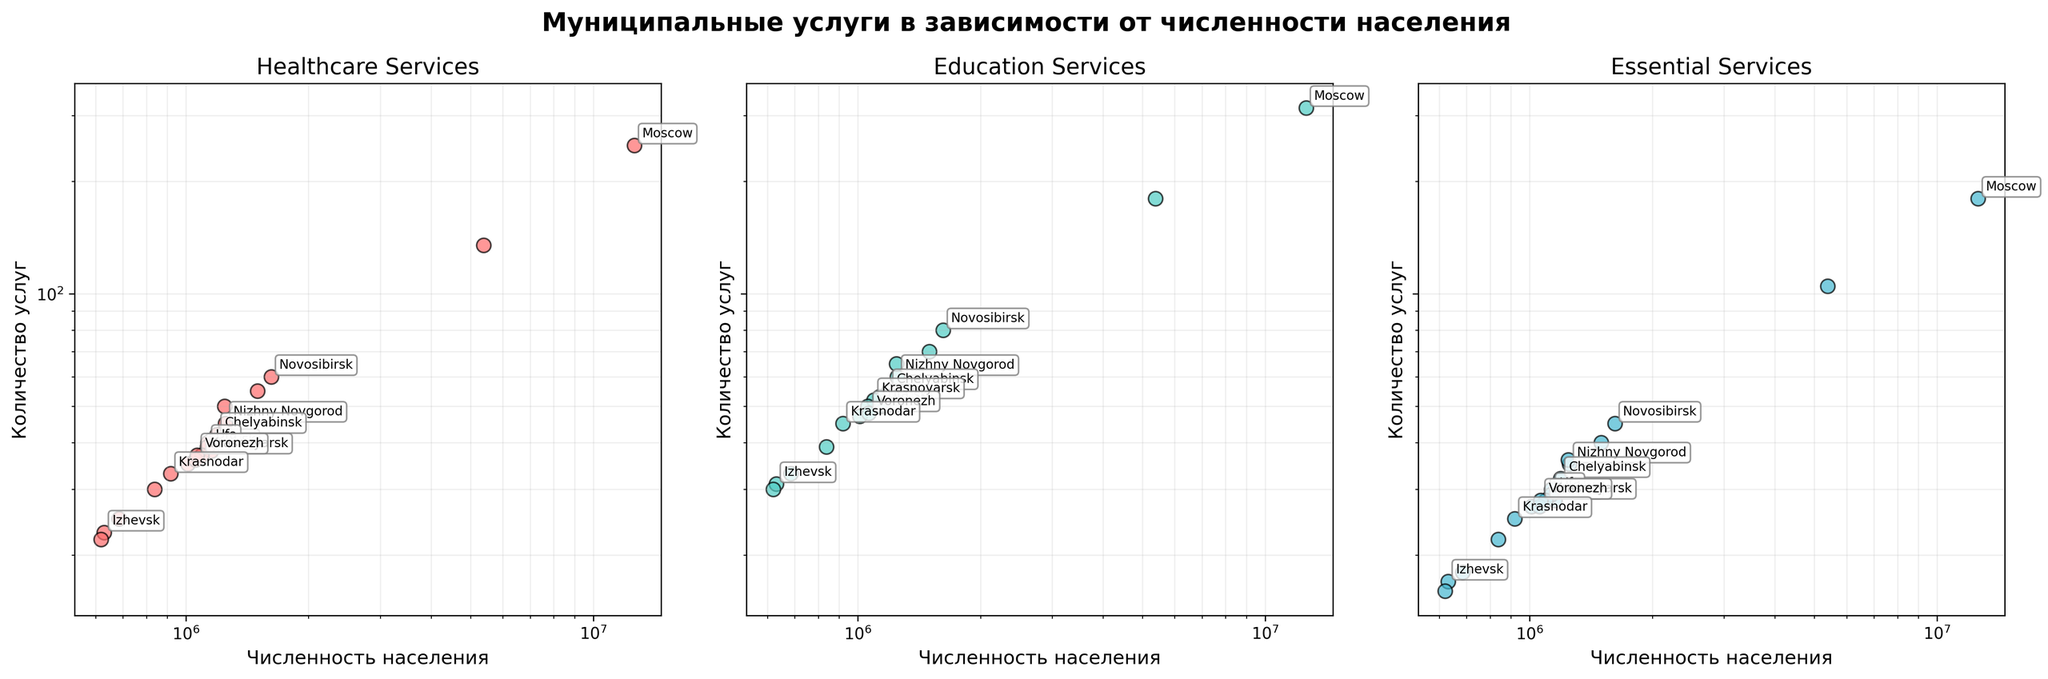Which city has the highest number of healthcare services? The plot shows each municipality's number of healthcare services along the y-axis. The city with the highest value is Moscow.
Answer: Moscow What is the relationship between population size and essential services? The log-log scale scatter plot suggests a positive correlation between population size and essential services since larger cities tend to offer more essential services.
Answer: Positive correlation What are the x-axis and y-axis labels? The x-axis represents the population size of the municipalities, and the y-axis represents the number of services provided. Each subplot specifies a different type of service: healthcare, education, and essential services.
Answer: Population and Number of Services Which city provides the most essential services, and how many does it offer? By examining the essential services subplot, it is evident that Moscow offers 180 essential services, the highest among the municipalities.
Answer: Moscow, 180 How does the number of education services in Saint Petersburg compare to that in Moscow? From the education services subplot, Moscow provides 315 education services whereas Saint Petersburg offers 180. Therefore, Moscow provides more education services than Saint Petersburg.
Answer: Moscow provides more On the healthcare services subplot, which city is closest to Kazan in terms of the number of services provided? Observing the plot, Chelyabinsk, which offers 42 healthcare services, is numerically closest to Kazan, which provides 50.
Answer: Chelyabinsk Are there any municipalities that provide fewer than 20 essential services? Referring to the essential services subplot, all municipalities provide more than 20 essential services.
Answer: No Which service type shows a wider spread in the number of services offered among municipalities? Comparison across the three subplots reveals that education services have the widest spread, ranging from 30 to 315 services.
Answer: Education services Which two cities are labeled closest to each other in the education services subplot? In the education services subplot, Kazan and Voronezh appear labeled near each other, providing 65 and 48 education services respectively.
Answer: Kazan, Voronezh What general trend do you observe across all three subplots regarding the number of services and population size? All three subplots suggest a positive trend where municipalities with larger populations generally offer more services, observable through the increasing values in log-log scale.
Answer: Larger populations, more services 